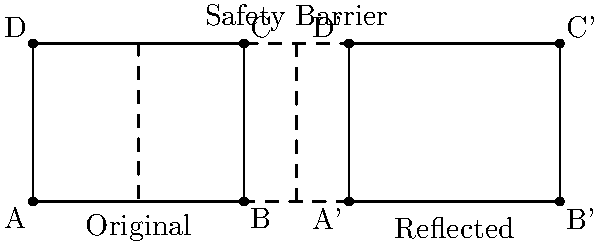Due to new safety regulations, you need to reflect your assembly line configuration across a newly installed safety barrier. The original assembly line is represented by rectangle ABCD, and the safety barrier is shown as a dashed line. What is the coordinate of point C' in the reflected configuration if the original point C is at (4,3)? To solve this problem, we need to follow these steps:

1. Identify the line of reflection: The safety barrier acts as the line of reflection, which is at x = 5.

2. Understand the reflection process: When reflecting a point across a vertical line, the x-coordinate changes, but the y-coordinate remains the same.

3. Calculate the distance from point C to the line of reflection:
   Distance = 5 - 4 = 1 unit

4. Reflect point C:
   - The reflected point C' will be the same distance from the line of reflection but on the opposite side.
   - So, C' will be 1 unit to the right of the line of reflection.

5. Determine the coordinates of C':
   - x-coordinate of C' = 5 + 1 = 6
   - y-coordinate of C' remains the same as C, which is 3

Therefore, the coordinates of C' are (6,3).
Answer: (6,3) 